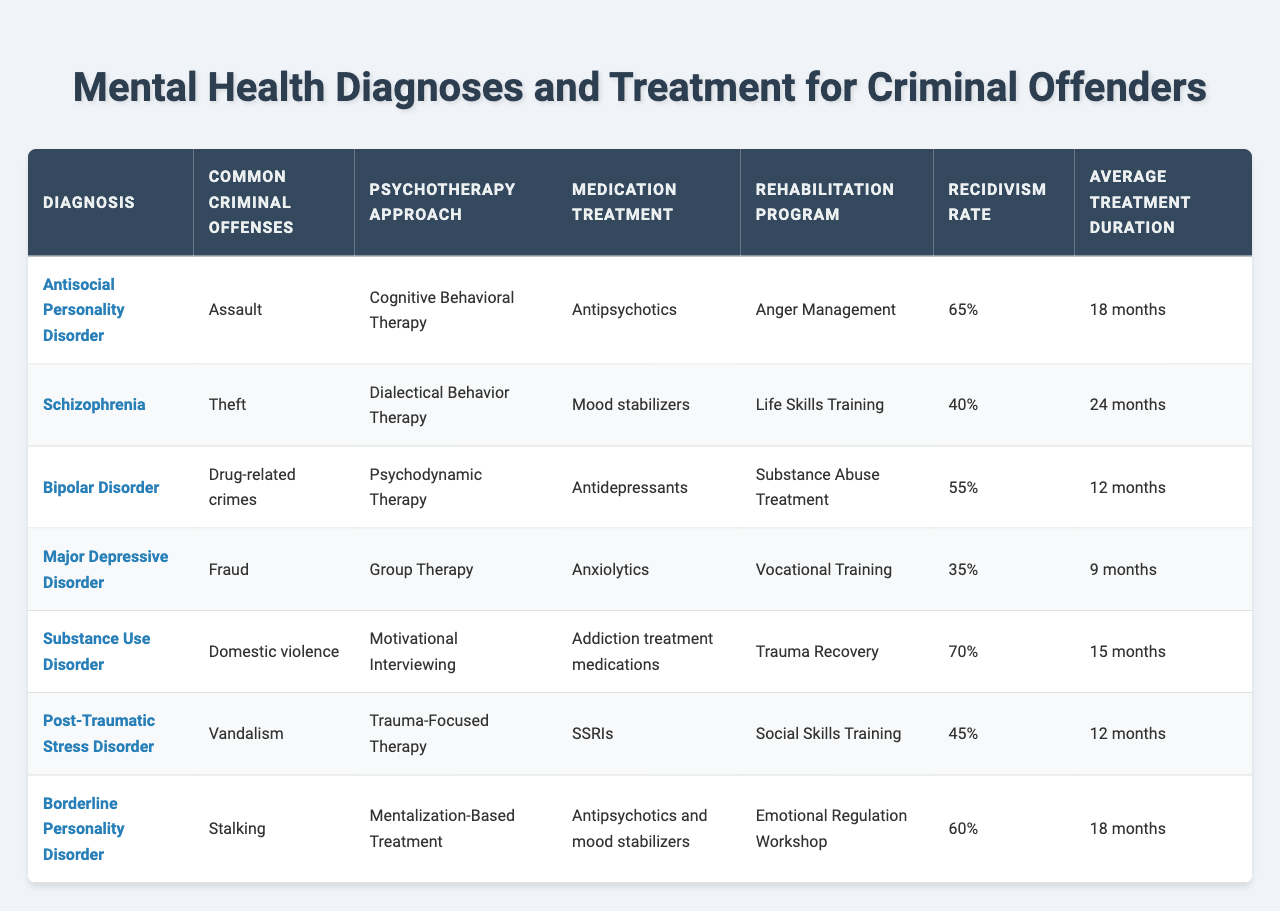What is the most common psychotherapy approach used for offenders with Antisocial Personality Disorder? According to the table, the psychotherapy approach listed for Antisocial Personality Disorder is Cognitive Behavioral Therapy.
Answer: Cognitive Behavioral Therapy Which diagnosis has the highest recidivism rate? The recidivism rates can be compared, and Substance Use Disorder has the highest rate at 70%.
Answer: Substance Use Disorder Is there a diagnosis listed that aligns with both major depressive disorder and bipolar disorder in terms of their treatment approach? The table indicates that Major Depressive Disorder is typically treated with Antidepressants, while Bipolar Disorder is managed with Mood stabilizers. Therefore, these two disorders have differing medication treatments.
Answer: No What is the average treatment duration for all listed diagnoses? To find the average treatment duration, we sum the durations (18 + 24 + 12 + 9 + 15 + 12 + 18 = 108 months) and then divide by the number of diagnoses (7), which results in an average duration of about 15.43 months.
Answer: 15.43 months Which diagnosis utilizes Dialectical Behavior Therapy, and what is its associated rehabilitation program? The table shows that Dialectical Behavior Therapy is used for Borderline Personality Disorder, which has the associated rehabilitation program of Emotional Regulation Workshop.
Answer: Emotional Regulation Workshop What are the two diagnoses that have a recidivism rate of 60% or higher? By examining the recidivism rates, Antisocial Personality Disorder (65%) and Substance Use Disorder (70%) are the two diagnoses with a rate of 60% or higher.
Answer: Antisocial Personality Disorder and Substance Use Disorder How many months does it take, on average, to treat offenders with PTSD and Bipolar Disorder? The average treatment duration for PTSD is 12 months, and for Bipolar Disorder is 12 months as well. Summing these gives 24 months, and averaging indicates both have the same duration.
Answer: 12 months True or False: The medication treatment for Schizophrenia is exclusively Antipsychotics. The table shows that the medication treatment for Schizophrenia is listed as Antipsychotics, but it does not specify that it is exclusive. Hence, this statement would be false since more than one treatment could exist.
Answer: False Which rehabilitation program is most commonly associated with offenders diagnosed with Major Depressive Disorder? The table indicates that the rehabilitation program associated with Major Depressive Disorder is Vocational Training, which is explicitly stated under its entry.
Answer: Vocational Training What is the relationship between the average treatment duration and the recidivism rate for Substance Use Disorder? The average treatment duration for Substance Use Disorder is 15 months, and its recidivism rate is 70%. The relationship shows that a higher rate of reoffending is linked with longer treatment duration in this case.
Answer: 15 months and 70% recidivism 